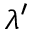Convert formula to latex. <formula><loc_0><loc_0><loc_500><loc_500>\lambda ^ { \prime }</formula> 